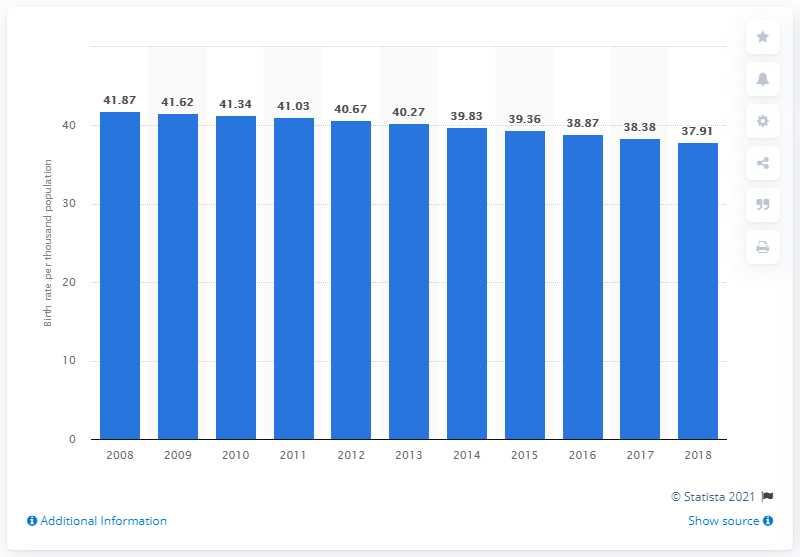Give some essential details in this illustration. In 2018, Nigeria's crude birth rate was 37.91. 